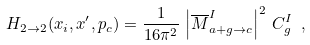Convert formula to latex. <formula><loc_0><loc_0><loc_500><loc_500>H _ { 2 \rightarrow 2 } ( x _ { i } , x ^ { \prime } , p _ { c } ) = \frac { 1 } { 1 6 \pi ^ { 2 } } \, \left | \overline { M } ^ { I } _ { a + g \rightarrow c } \right | ^ { 2 } \, C ^ { I } _ { g } \ ,</formula> 